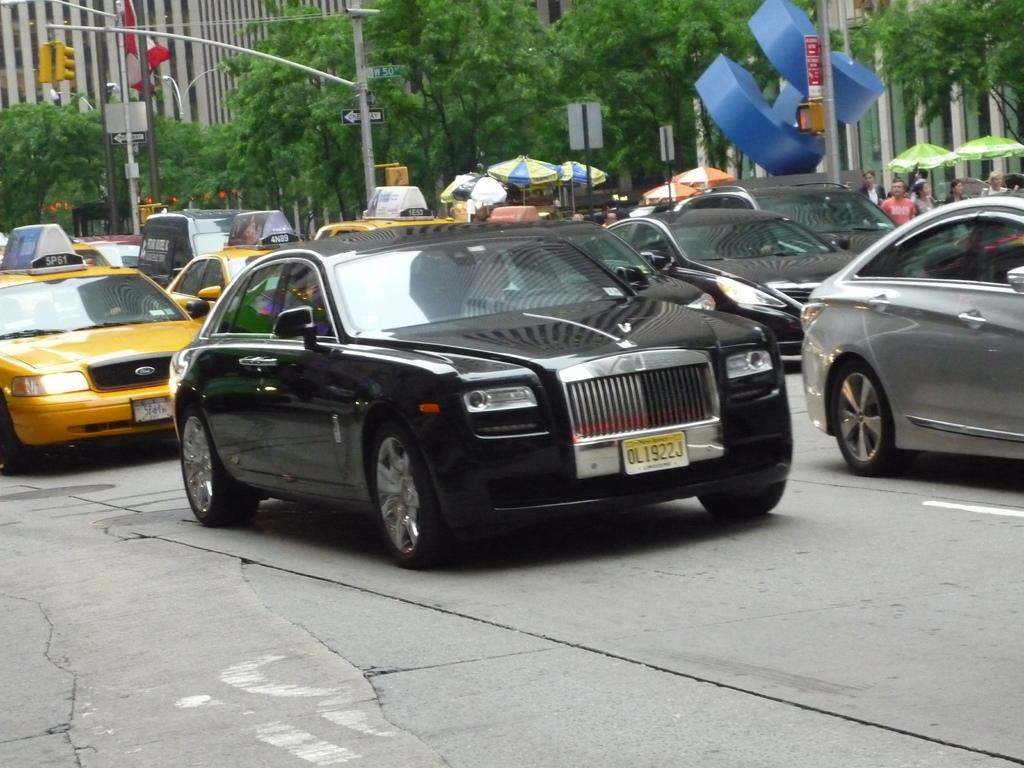Provide a one-sentence caption for the provided image. A black luxury vehicle with the license plate OL1922J. 